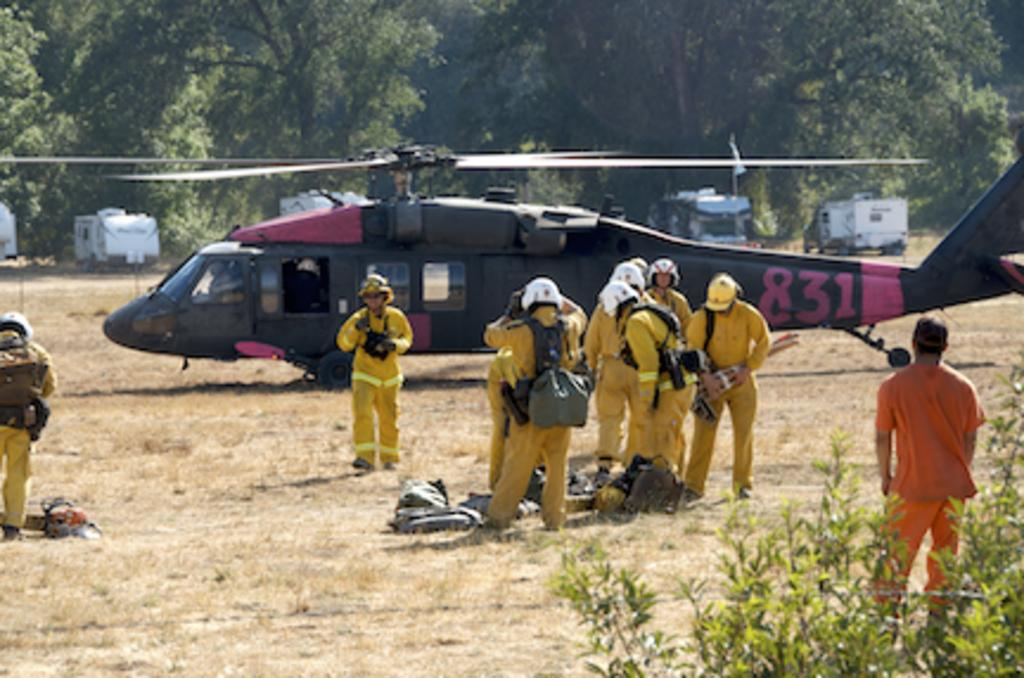Provide a one-sentence caption for the provided image. Red and black helicopter with a red number 831. 